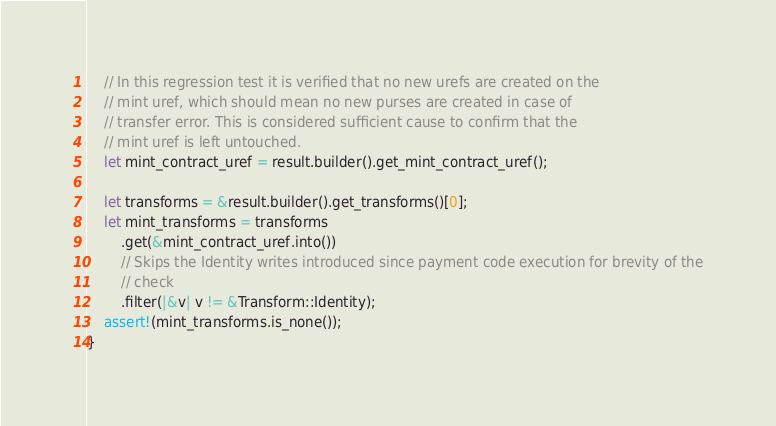<code> <loc_0><loc_0><loc_500><loc_500><_Rust_>
    // In this regression test it is verified that no new urefs are created on the
    // mint uref, which should mean no new purses are created in case of
    // transfer error. This is considered sufficient cause to confirm that the
    // mint uref is left untouched.
    let mint_contract_uref = result.builder().get_mint_contract_uref();

    let transforms = &result.builder().get_transforms()[0];
    let mint_transforms = transforms
        .get(&mint_contract_uref.into())
        // Skips the Identity writes introduced since payment code execution for brevity of the
        // check
        .filter(|&v| v != &Transform::Identity);
    assert!(mint_transforms.is_none());
}
</code> 